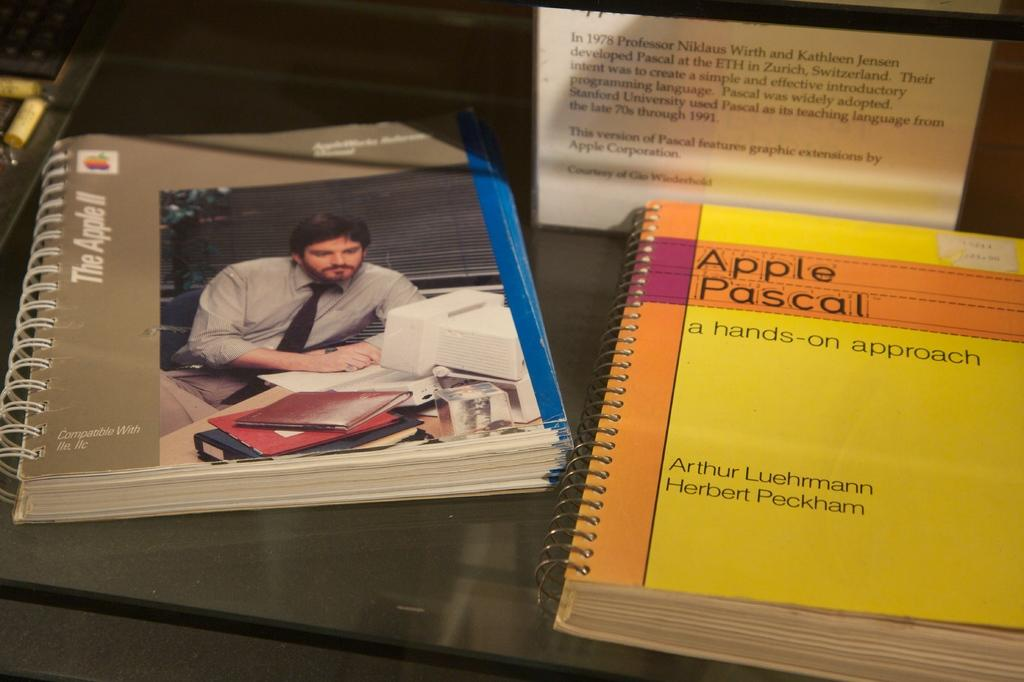Provide a one-sentence caption for the provided image. manual for apple IIc and IIe along with apple pascal book. 